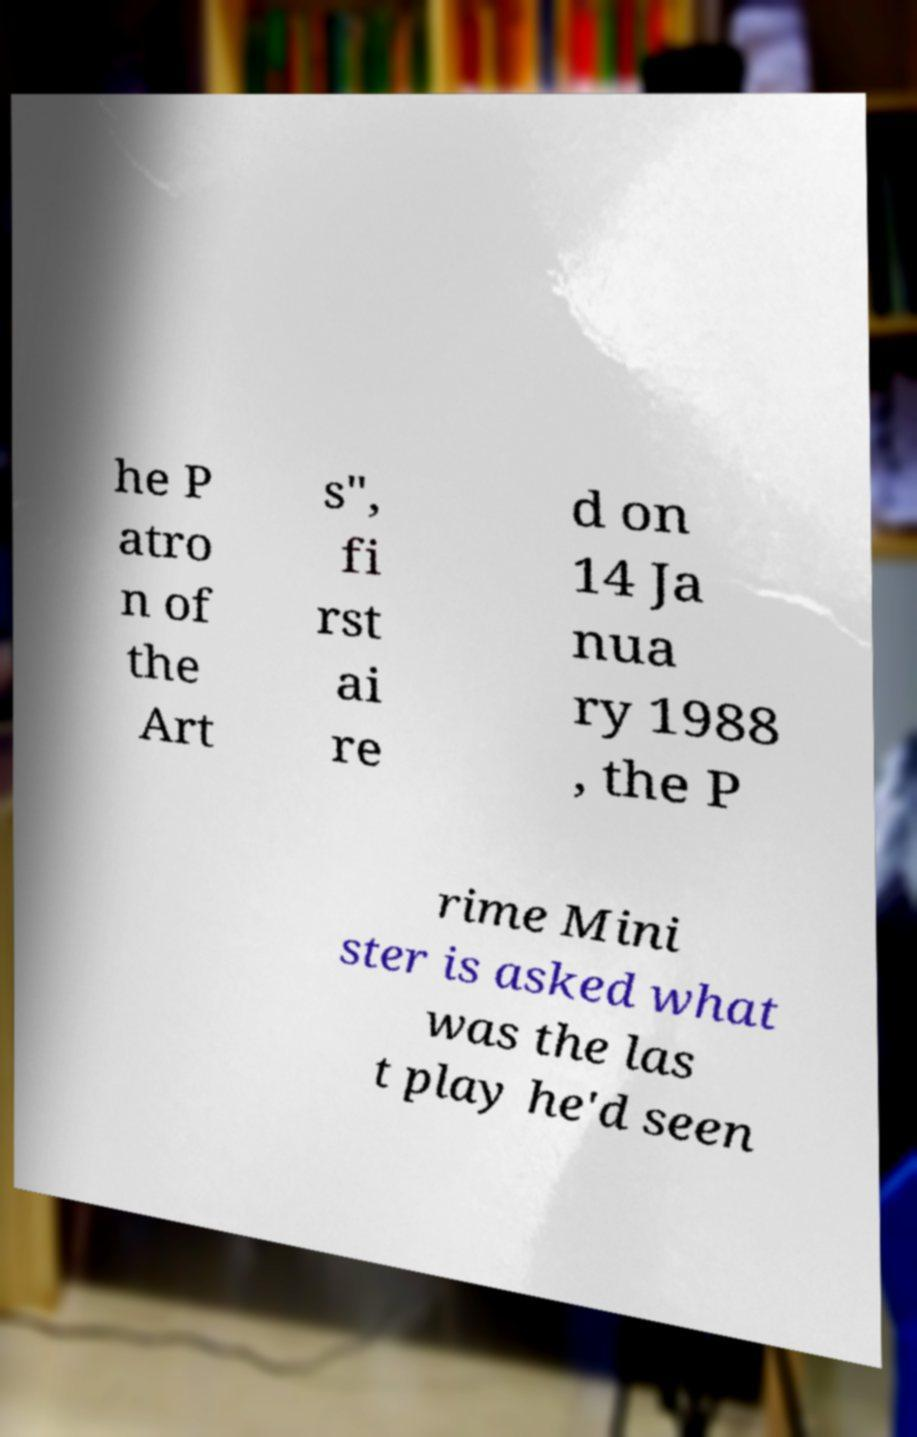Please identify and transcribe the text found in this image. he P atro n of the Art s", fi rst ai re d on 14 Ja nua ry 1988 , the P rime Mini ster is asked what was the las t play he'd seen 